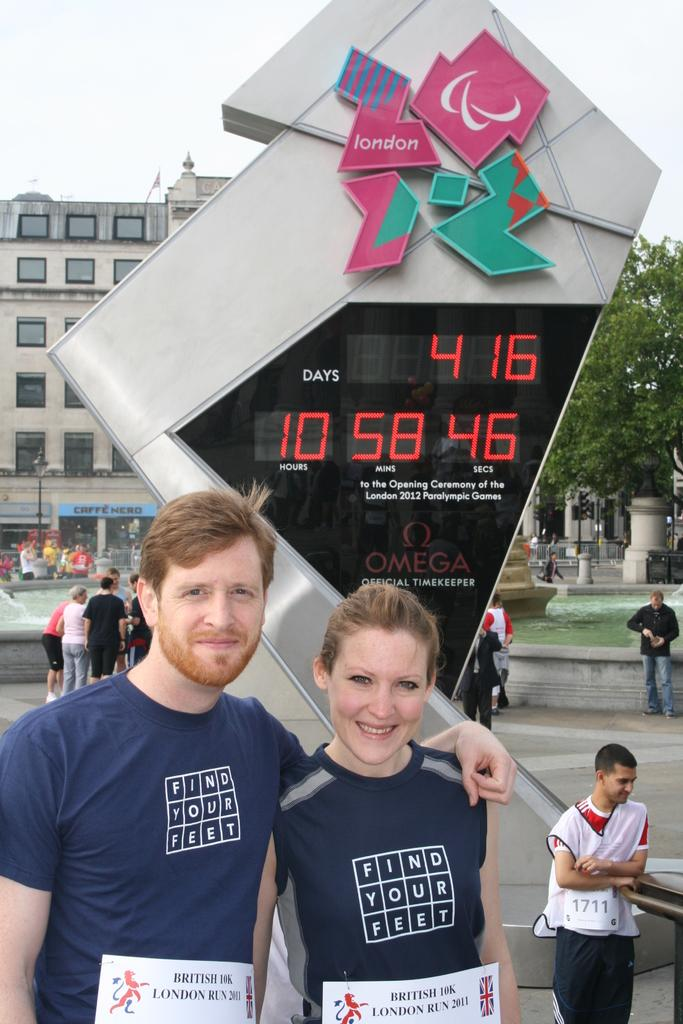How many people are present in the image? There are two people in the image. What can be seen on the dresses of the two people? The people have posters on their dresses. Can you describe the surroundings in the image? There are other people visible in the image, as well as a building. What is displayed on the screen in the image? There is a screen displaying text in the image. What decision did the people make during the rainstorm in the image? There is no rainstorm present in the image, and therefore no decision-making related to a rainstorm can be observed. 